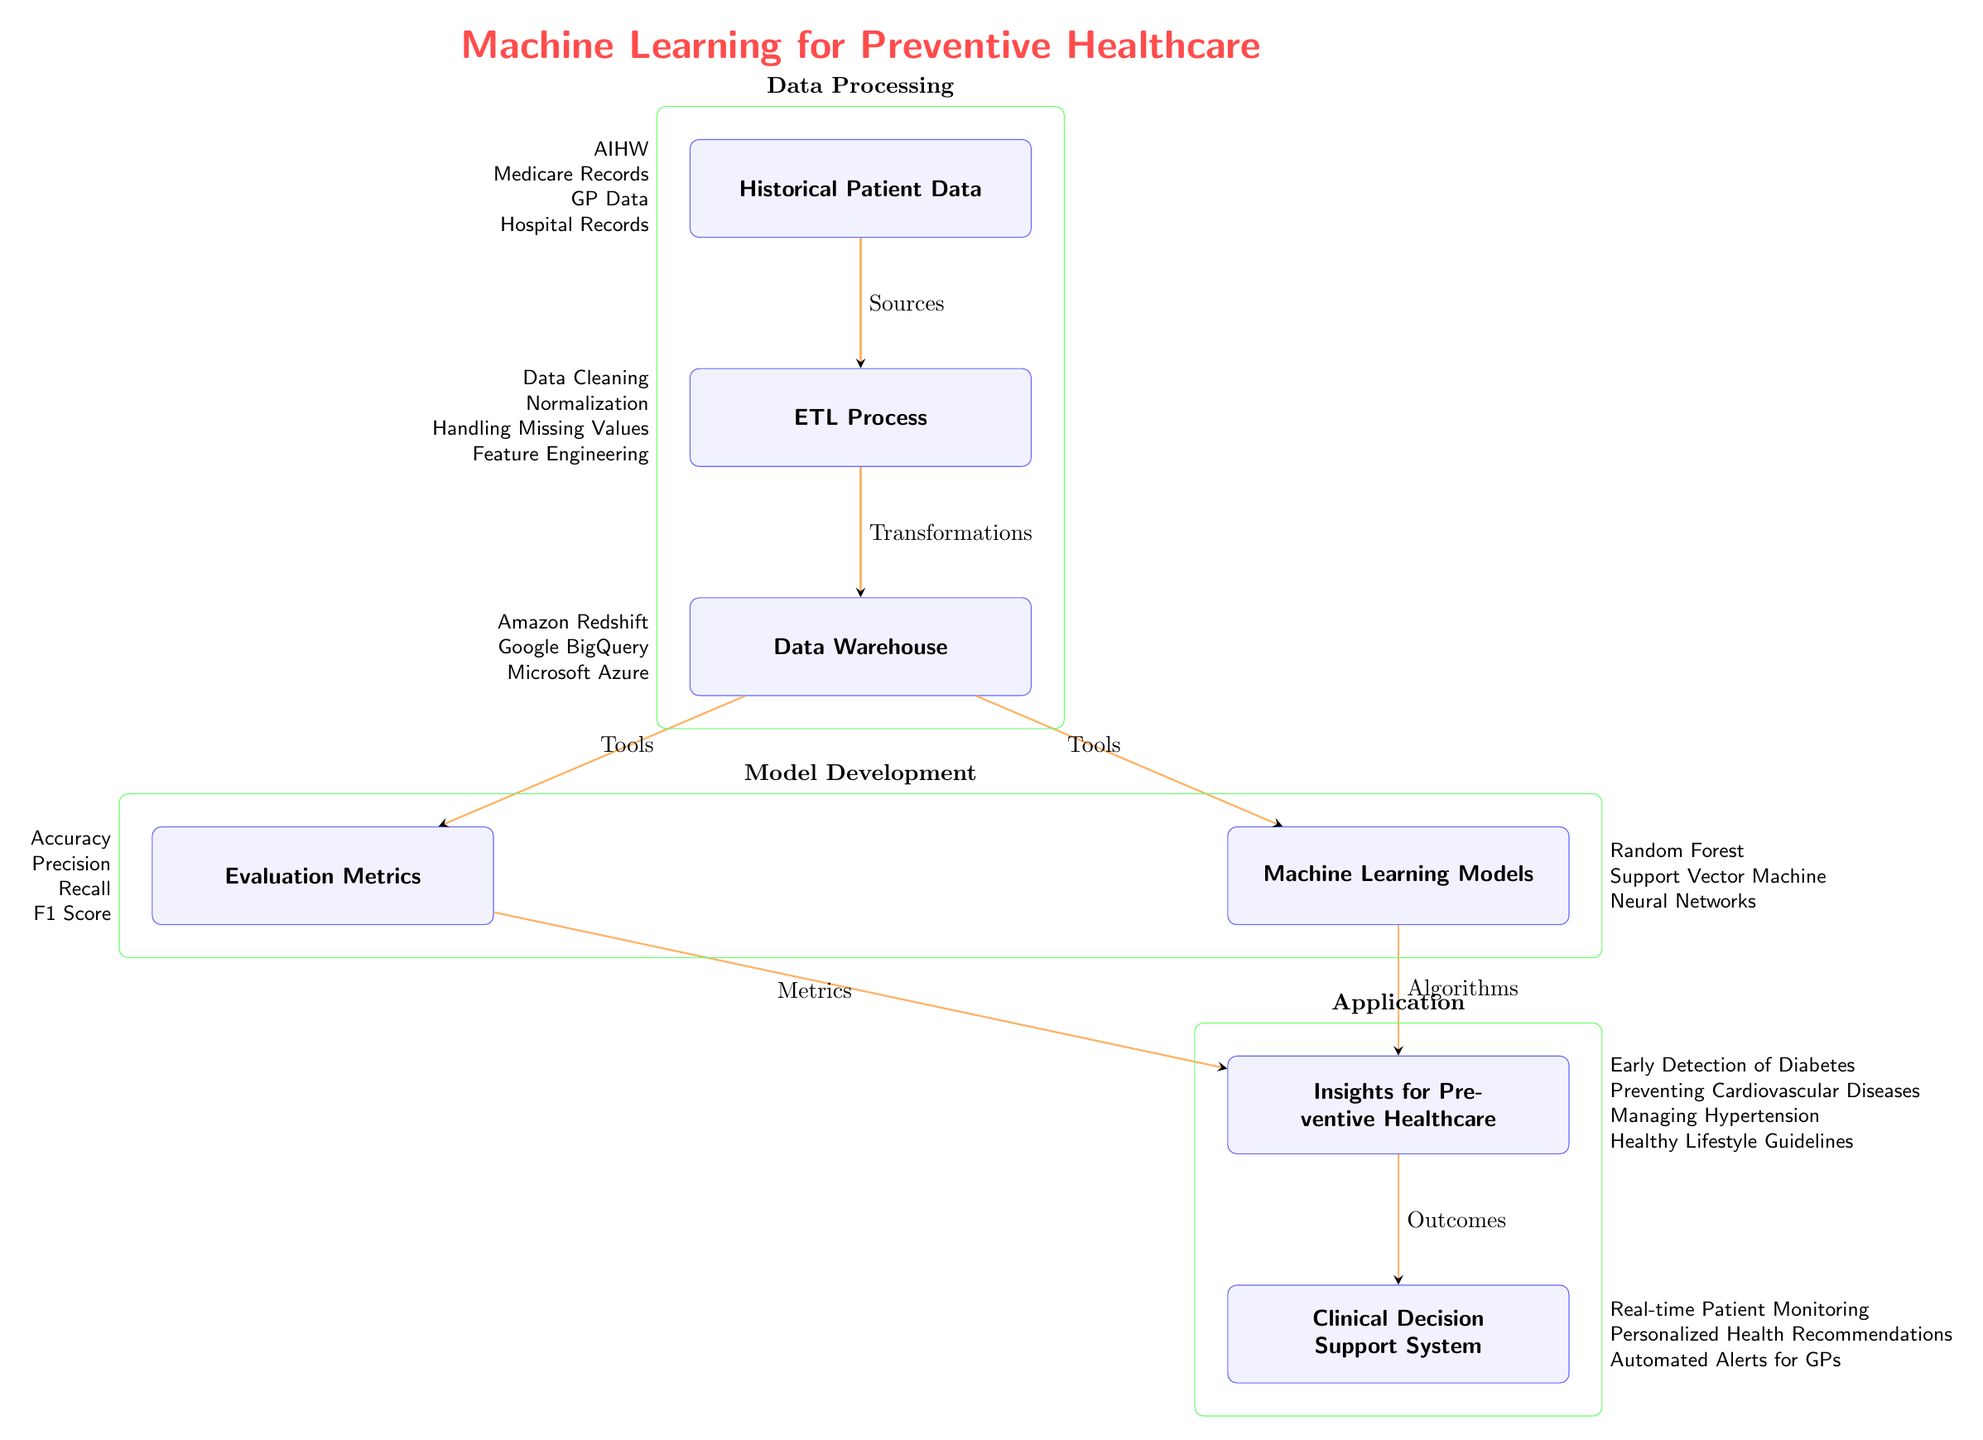What's the first node in the diagram? The diagram starts with the node labeled "Historical Patient Data." This is the first element in the flow, indicating that the process begins with collecting historical patient information.
Answer: Historical Patient Data How many nodes are there in total? By counting all the distinct boxes in the diagram, we find there are six nodes: Historical Patient Data, ETL Process, Data Warehouse, Machine Learning Models, Evaluation Metrics, and Insights for Preventive Healthcare.
Answer: Six What does the ETL Process node output to the Data Warehouse? The ETL Process node outputs "Transformations" to the Data Warehouse. This indicates that the data is transformed before being stored in the warehouse.
Answer: Transformations Which tool is listed under the Data Warehouse? The Data Warehouse node includes several tools, one of which is "Amazon Redshift." This highlights that Amazon Redshift can be used as a solution for storing the data.
Answer: Amazon Redshift What is the final outcome of the insights from the Machine Learning Models? The final outcome resulting from the insights is "Clinical Decision Support System." This indicates that the insights are translated into a system that supports clinical decisions.
Answer: Clinical Decision Support System What metrics are used for evaluating the Machine Learning Models? The Evaluation Metrics node lists several metrics, one of which is "Accuracy." This indicates that accuracy is one of the performance indicators used to evaluate the models.
Answer: Accuracy What type of algorithms are employed in the Machine Learning Models? The Machine Learning Models node specifies several types of algorithms, including "Random Forest." This indicates that Random Forest is one of the algorithms used in the predictive modeling process.
Answer: Random Forest How are the insights from the diagram utilized in healthcare? The insights derived from the diagram are utilized as "Outcomes," which feed into the Clinical Decision Support System, thus directly impacting healthcare.
Answer: Outcomes Which group contains the nodes related to data processing? The Data Processing group incorporates the nodes: Historical Patient Data, ETL Process, and Data Warehouse. This is organized to show that these nodes work together for data processing tasks.
Answer: Data Processing 